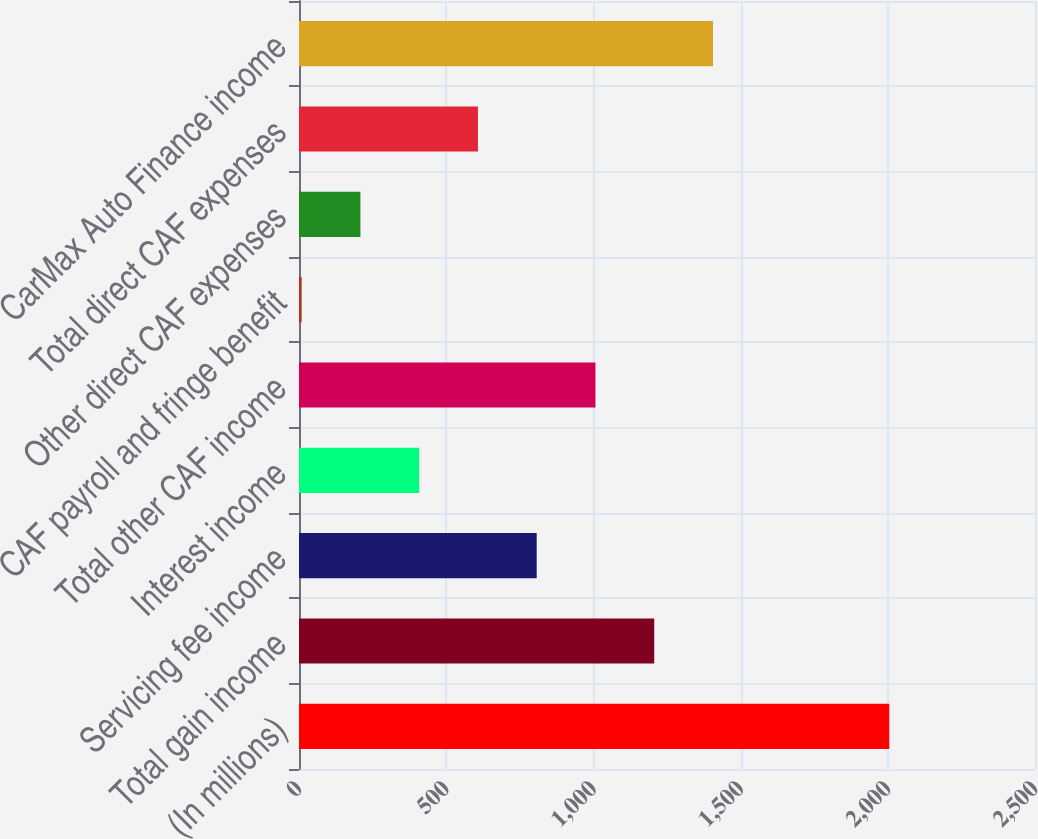Convert chart to OTSL. <chart><loc_0><loc_0><loc_500><loc_500><bar_chart><fcel>(In millions)<fcel>Total gain income<fcel>Servicing fee income<fcel>Interest income<fcel>Total other CAF income<fcel>CAF payroll and fringe benefit<fcel>Other direct CAF expenses<fcel>Total direct CAF expenses<fcel>CarMax Auto Finance income<nl><fcel>2005<fcel>1206.6<fcel>807.4<fcel>408.2<fcel>1007<fcel>9<fcel>208.6<fcel>607.8<fcel>1406.2<nl></chart> 